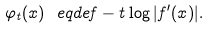<formula> <loc_0><loc_0><loc_500><loc_500>\varphi _ { t } ( x ) \ e q d e f - t \log | f ^ { \prime } ( x ) | .</formula> 